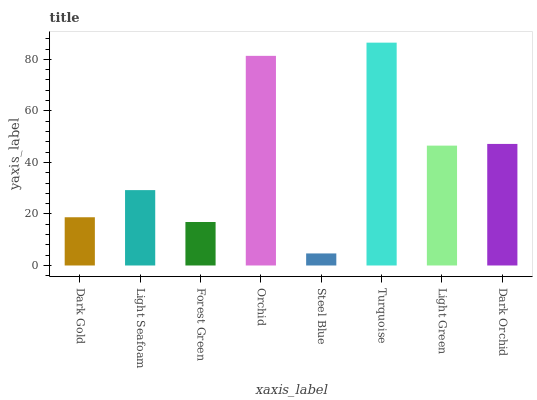Is Steel Blue the minimum?
Answer yes or no. Yes. Is Turquoise the maximum?
Answer yes or no. Yes. Is Light Seafoam the minimum?
Answer yes or no. No. Is Light Seafoam the maximum?
Answer yes or no. No. Is Light Seafoam greater than Dark Gold?
Answer yes or no. Yes. Is Dark Gold less than Light Seafoam?
Answer yes or no. Yes. Is Dark Gold greater than Light Seafoam?
Answer yes or no. No. Is Light Seafoam less than Dark Gold?
Answer yes or no. No. Is Light Green the high median?
Answer yes or no. Yes. Is Light Seafoam the low median?
Answer yes or no. Yes. Is Orchid the high median?
Answer yes or no. No. Is Dark Gold the low median?
Answer yes or no. No. 